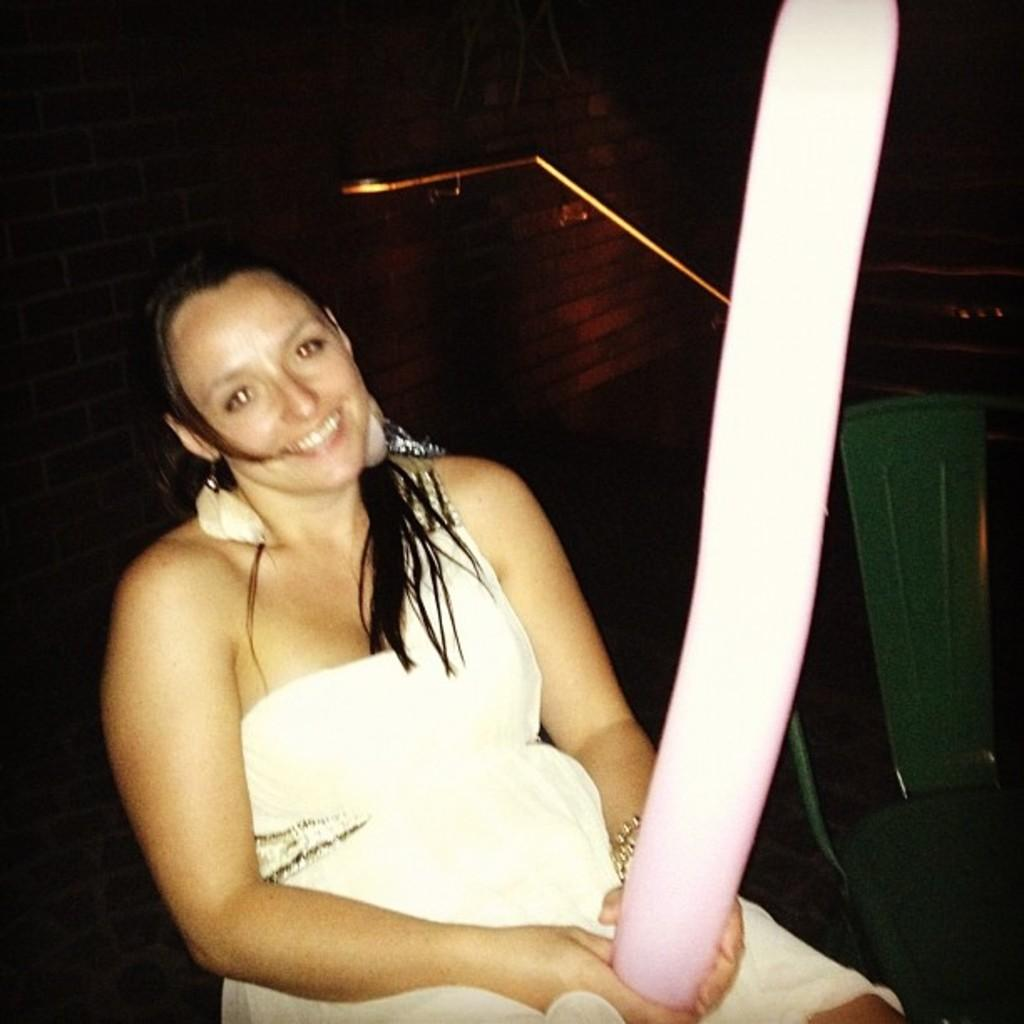Who is present in the image? There is a woman in the image. What is the woman wearing? The woman is wearing a white dress. What is the woman holding in the image? The woman is holding something. What can be seen in the background of the image? There is a wall visible in the background of the image. How would you describe the lighting in the image? The image is dark. How many stars can be seen on the sofa in the image? There is no sofa or stars present in the image. 